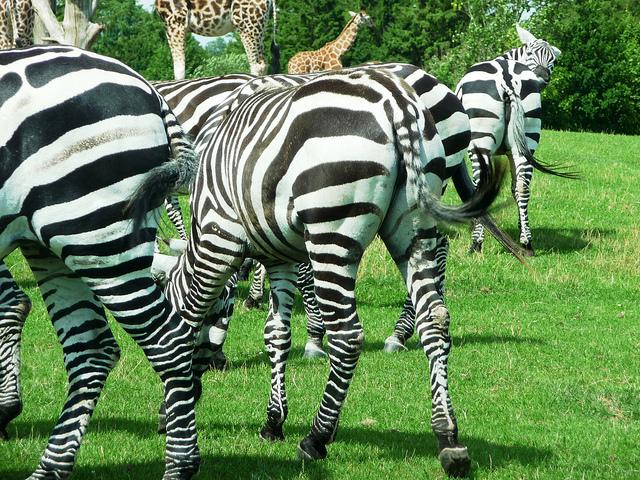How many animals are in this picture?
Write a very short answer. 7. How many different types of animals are there?
Keep it brief. 2. Do giraffes and zebras seem to get along?
Give a very brief answer. Yes. 